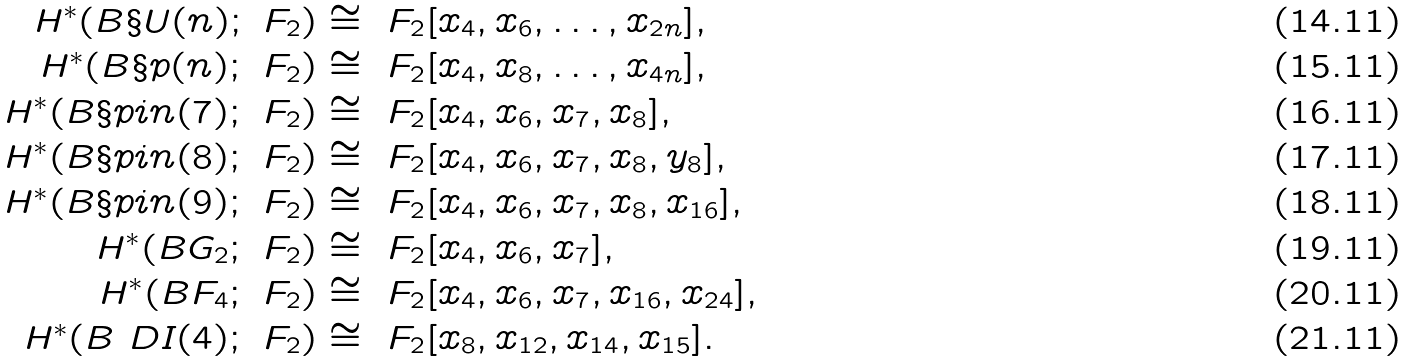Convert formula to latex. <formula><loc_0><loc_0><loc_500><loc_500>H ^ { * } ( B \S U ( n ) ; \ F _ { 2 } ) & \cong \ F _ { 2 } [ x _ { 4 } , x _ { 6 } , \dots , x _ { 2 n } ] , \\ H ^ { * } ( B \S p ( n ) ; \ F _ { 2 } ) & \cong \ F _ { 2 } [ x _ { 4 } , x _ { 8 } , \dots , x _ { 4 n } ] , \\ H ^ { * } ( B \S p i n ( 7 ) ; \ F _ { 2 } ) & \cong \ F _ { 2 } [ x _ { 4 } , x _ { 6 } , x _ { 7 } , x _ { 8 } ] , \\ H ^ { * } ( B \S p i n ( 8 ) ; \ F _ { 2 } ) & \cong \ F _ { 2 } [ x _ { 4 } , x _ { 6 } , x _ { 7 } , x _ { 8 } , y _ { 8 } ] , \\ H ^ { * } ( B \S p i n ( 9 ) ; \ F _ { 2 } ) & \cong \ F _ { 2 } [ x _ { 4 } , x _ { 6 } , x _ { 7 } , x _ { 8 } , x _ { 1 6 } ] , \\ H ^ { * } ( B G _ { 2 } ; \ F _ { 2 } ) & \cong \ F _ { 2 } [ x _ { 4 } , x _ { 6 } , x _ { 7 } ] , \\ H ^ { * } ( B F _ { 4 } ; \ F _ { 2 } ) & \cong \ F _ { 2 } [ x _ { 4 } , x _ { 6 } , x _ { 7 } , x _ { 1 6 } , x _ { 2 4 } ] , \\ H ^ { * } ( B \ D I ( 4 ) ; \ F _ { 2 } ) & \cong \ F _ { 2 } [ x _ { 8 } , x _ { 1 2 } , x _ { 1 4 } , x _ { 1 5 } ] .</formula> 